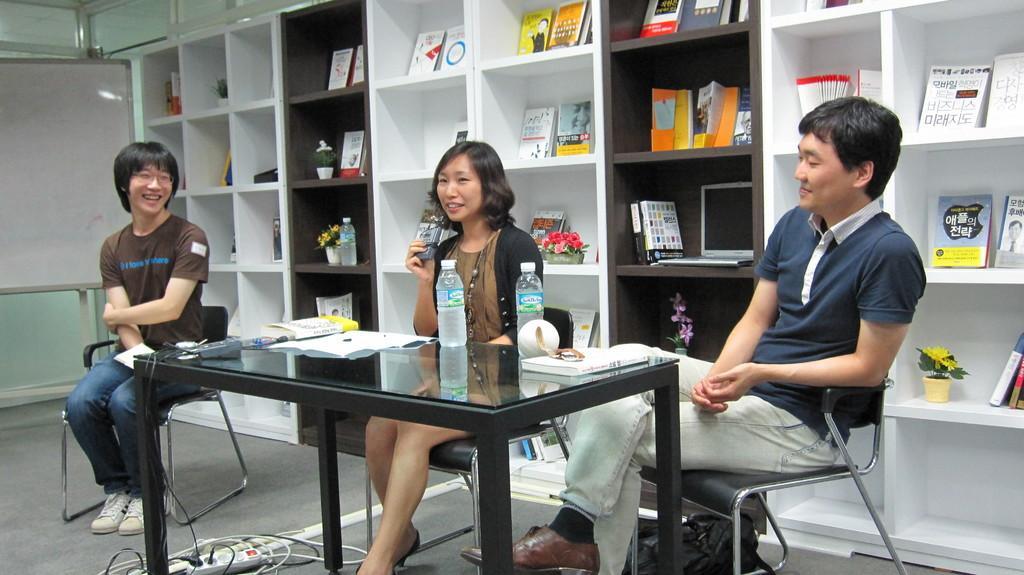Describe this image in one or two sentences. In this picture I can see water bottles, papers and couple of books on the table and I can see few books in the shelves and I can see a laptop and I can see white board on the left side of the picture and looks like few artificial plants with flowers in the pots and I can see woman holding something in her hand. 